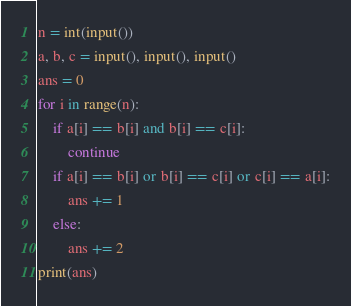Convert code to text. <code><loc_0><loc_0><loc_500><loc_500><_Python_>n = int(input())
a, b, c = input(), input(), input()
ans = 0
for i in range(n):
    if a[i] == b[i] and b[i] == c[i]:
        continue
    if a[i] == b[i] or b[i] == c[i] or c[i] == a[i]:
        ans += 1
    else:
        ans += 2
print(ans)</code> 